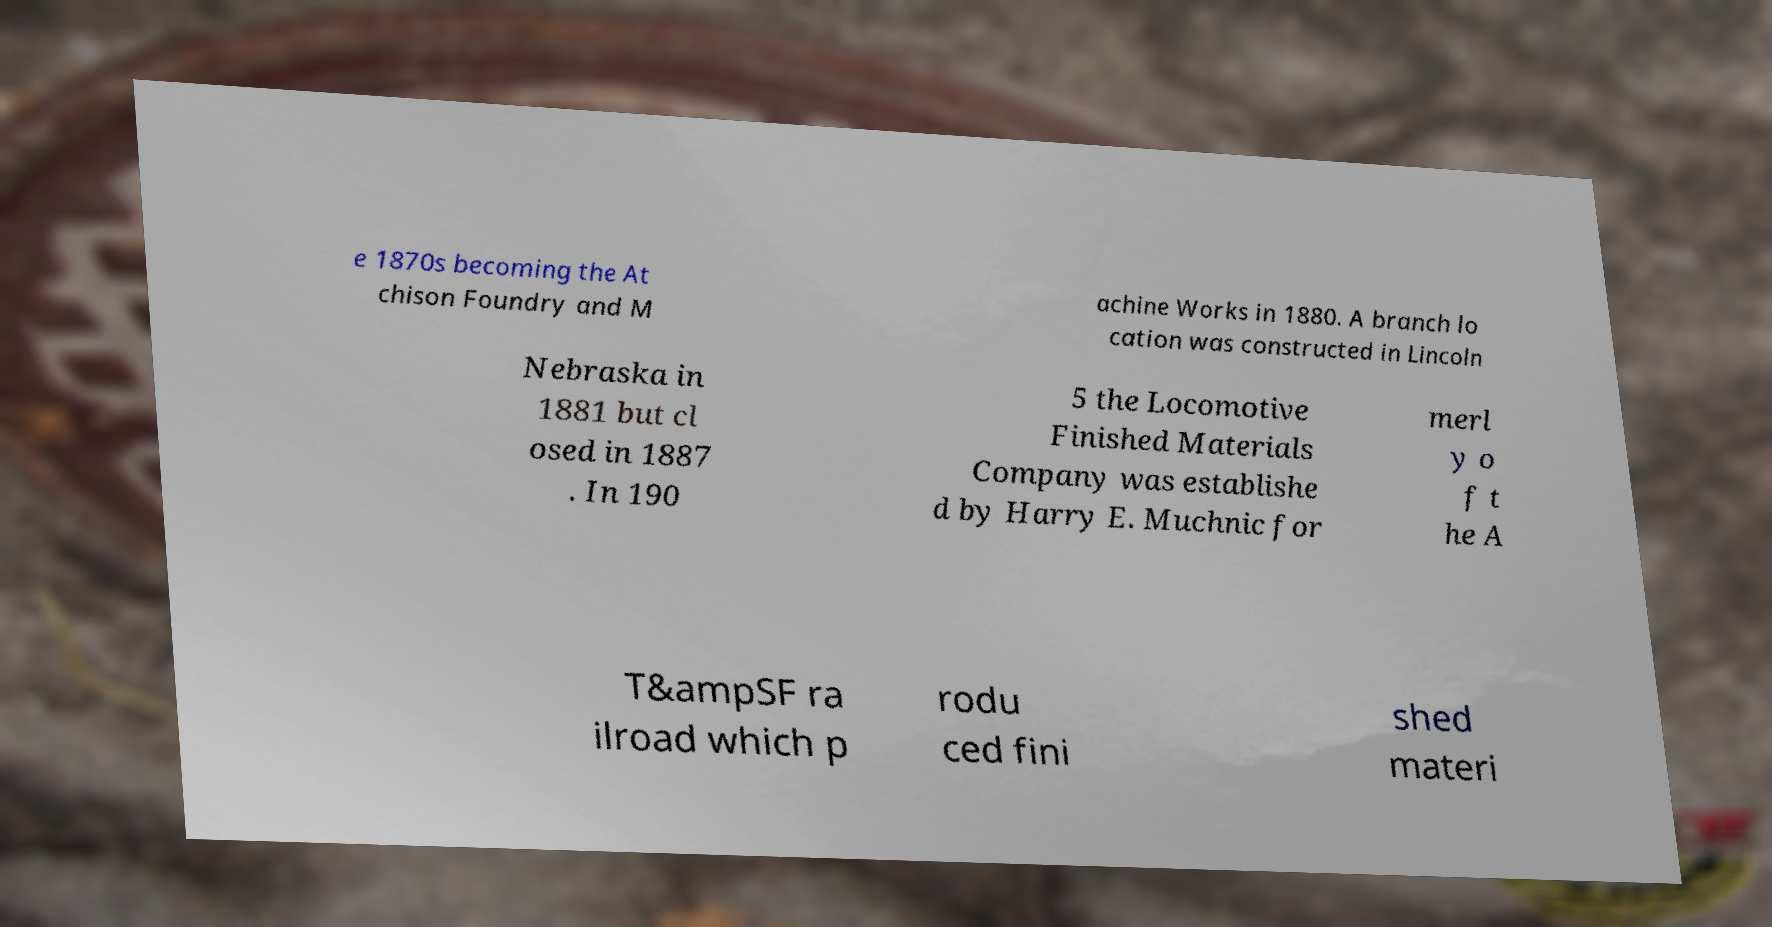Could you assist in decoding the text presented in this image and type it out clearly? e 1870s becoming the At chison Foundry and M achine Works in 1880. A branch lo cation was constructed in Lincoln Nebraska in 1881 but cl osed in 1887 . In 190 5 the Locomotive Finished Materials Company was establishe d by Harry E. Muchnic for merl y o f t he A T&ampSF ra ilroad which p rodu ced fini shed materi 